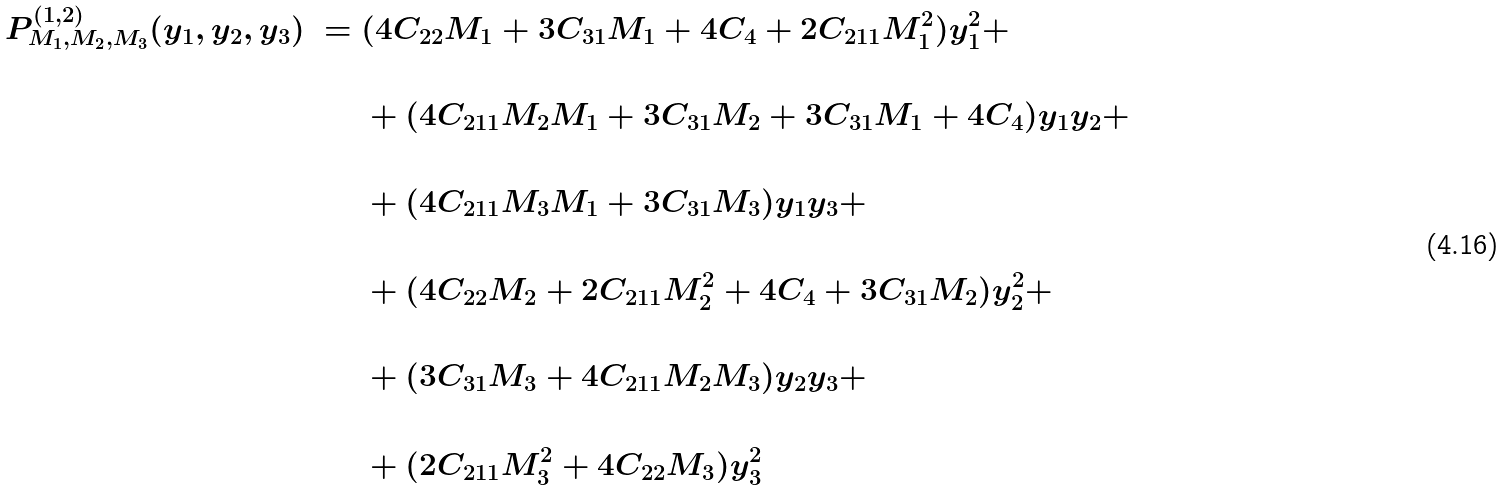<formula> <loc_0><loc_0><loc_500><loc_500>P ^ { ( 1 , 2 ) } _ { M _ { 1 } , M _ { 2 } , M _ { 3 } } ( y _ { 1 } , y _ { 2 } , y _ { 3 } ) \ = \ & ( 4 C _ { 2 2 } M _ { 1 } + 3 C _ { 3 1 } M _ { 1 } + 4 C _ { 4 } + 2 C _ { 2 1 1 } M _ { 1 } ^ { 2 } ) y _ { 1 } ^ { 2 } + \\ & \\ & + ( 4 C _ { 2 1 1 } M _ { 2 } M _ { 1 } + 3 C _ { 3 1 } M _ { 2 } + 3 C _ { 3 1 } M _ { 1 } + 4 C _ { 4 } ) y _ { 1 } y _ { 2 } + \\ & \\ & + ( 4 C _ { 2 1 1 } M _ { 3 } M _ { 1 } + 3 C _ { 3 1 } M _ { 3 } ) y _ { 1 } y _ { 3 } + \\ & \\ & + ( 4 C _ { 2 2 } M _ { 2 } + 2 C _ { 2 1 1 } M _ { 2 } ^ { 2 } + 4 C _ { 4 } + 3 C _ { 3 1 } M _ { 2 } ) y _ { 2 } ^ { 2 } + \\ & \\ & + ( 3 C _ { 3 1 } M _ { 3 } + 4 C _ { 2 1 1 } M _ { 2 } M _ { 3 } ) y _ { 2 } y _ { 3 } + \\ & \\ & + ( 2 C _ { 2 1 1 } M _ { 3 } ^ { 2 } + 4 C _ { 2 2 } M _ { 3 } ) y _ { 3 } ^ { 2 }</formula> 